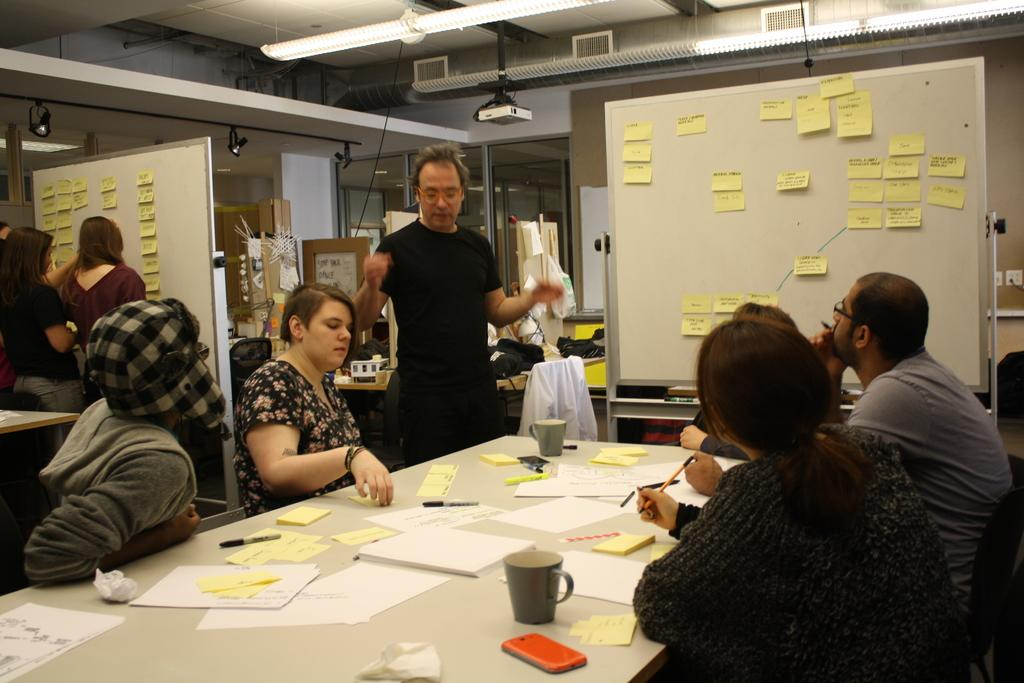What are the people in the image doing? There are people sitting on chairs and people standing in the image. Can you describe the positions of the people in the image? Some people are sitting on chairs, while others are standing. What type of cakes are being served to the people in the image? There is no mention of cakes or any food items in the image. Are the people in the image wearing vests? The image does not provide information about the clothing of the people, so it cannot be determined if they are wearing vests. 